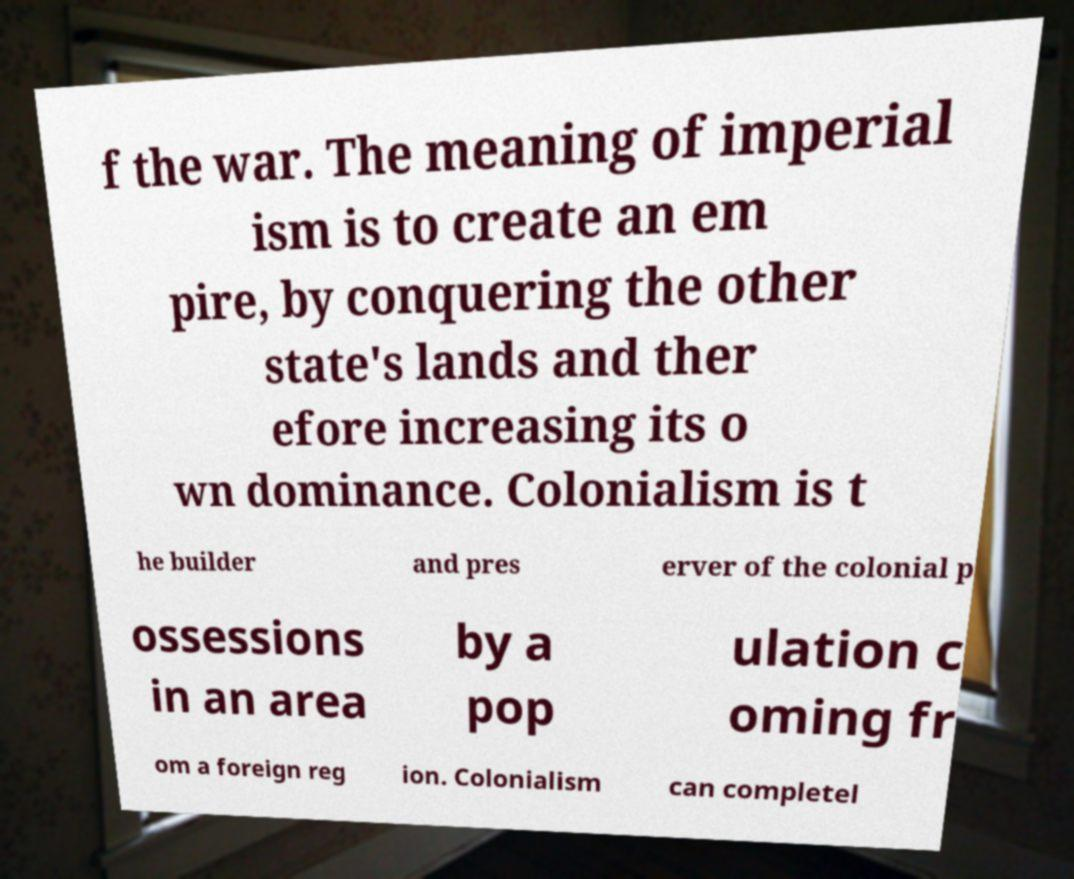Could you extract and type out the text from this image? f the war. The meaning of imperial ism is to create an em pire, by conquering the other state's lands and ther efore increasing its o wn dominance. Colonialism is t he builder and pres erver of the colonial p ossessions in an area by a pop ulation c oming fr om a foreign reg ion. Colonialism can completel 